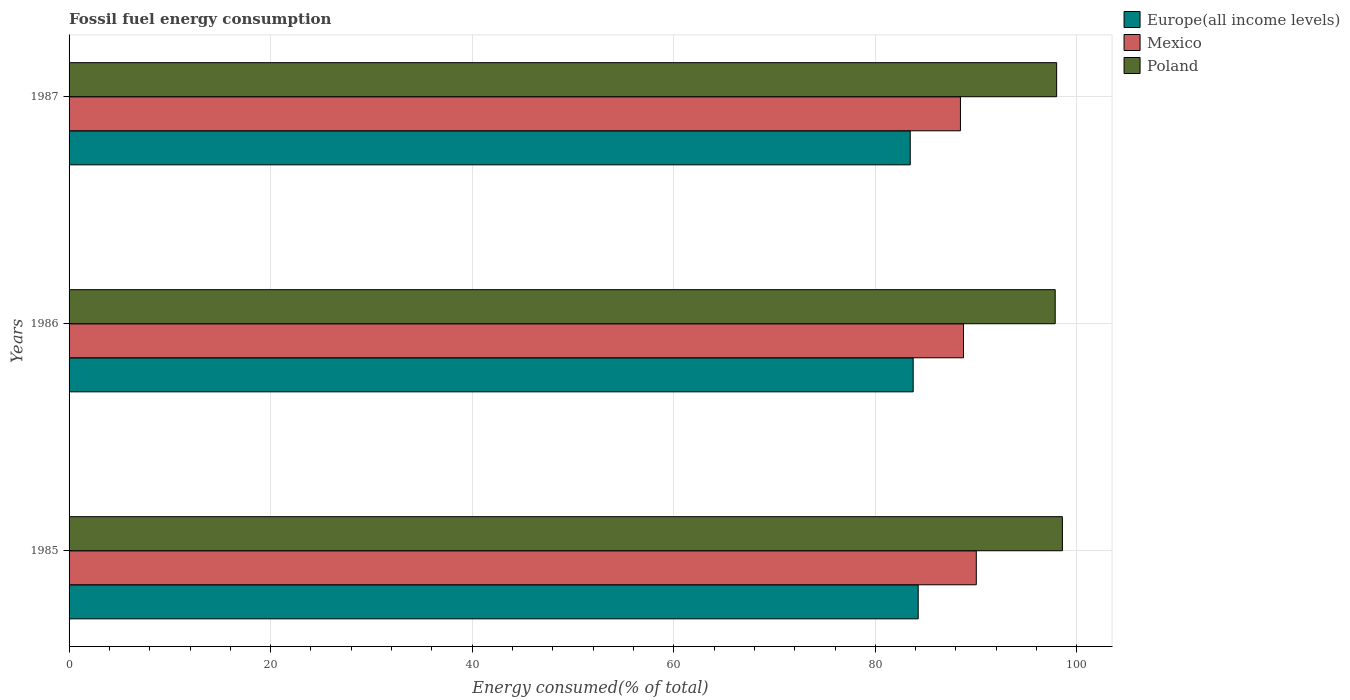How many different coloured bars are there?
Your answer should be compact. 3. Are the number of bars per tick equal to the number of legend labels?
Your response must be concise. Yes. What is the label of the 2nd group of bars from the top?
Offer a very short reply. 1986. In how many cases, is the number of bars for a given year not equal to the number of legend labels?
Make the answer very short. 0. What is the percentage of energy consumed in Poland in 1986?
Your answer should be compact. 97.85. Across all years, what is the maximum percentage of energy consumed in Mexico?
Give a very brief answer. 90.02. Across all years, what is the minimum percentage of energy consumed in Europe(all income levels)?
Make the answer very short. 83.46. In which year was the percentage of energy consumed in Poland minimum?
Provide a succinct answer. 1986. What is the total percentage of energy consumed in Mexico in the graph?
Your response must be concise. 267.21. What is the difference between the percentage of energy consumed in Europe(all income levels) in 1985 and that in 1987?
Offer a very short reply. 0.79. What is the difference between the percentage of energy consumed in Mexico in 1985 and the percentage of energy consumed in Poland in 1986?
Provide a succinct answer. -7.83. What is the average percentage of energy consumed in Mexico per year?
Ensure brevity in your answer.  89.07. In the year 1987, what is the difference between the percentage of energy consumed in Europe(all income levels) and percentage of energy consumed in Poland?
Give a very brief answer. -14.53. What is the ratio of the percentage of energy consumed in Mexico in 1985 to that in 1987?
Provide a short and direct response. 1.02. What is the difference between the highest and the second highest percentage of energy consumed in Poland?
Your answer should be compact. 0.57. What is the difference between the highest and the lowest percentage of energy consumed in Europe(all income levels)?
Your answer should be very brief. 0.79. In how many years, is the percentage of energy consumed in Europe(all income levels) greater than the average percentage of energy consumed in Europe(all income levels) taken over all years?
Make the answer very short. 1. What does the 2nd bar from the top in 1985 represents?
Your answer should be very brief. Mexico. What does the 1st bar from the bottom in 1985 represents?
Keep it short and to the point. Europe(all income levels). Is it the case that in every year, the sum of the percentage of energy consumed in Europe(all income levels) and percentage of energy consumed in Mexico is greater than the percentage of energy consumed in Poland?
Keep it short and to the point. Yes. How many bars are there?
Your answer should be compact. 9. Are all the bars in the graph horizontal?
Your answer should be compact. Yes. How many years are there in the graph?
Offer a very short reply. 3. Does the graph contain grids?
Provide a succinct answer. Yes. How many legend labels are there?
Offer a very short reply. 3. How are the legend labels stacked?
Ensure brevity in your answer.  Vertical. What is the title of the graph?
Your response must be concise. Fossil fuel energy consumption. Does "St. Kitts and Nevis" appear as one of the legend labels in the graph?
Your answer should be compact. No. What is the label or title of the X-axis?
Keep it short and to the point. Energy consumed(% of total). What is the Energy consumed(% of total) in Europe(all income levels) in 1985?
Keep it short and to the point. 84.25. What is the Energy consumed(% of total) in Mexico in 1985?
Offer a very short reply. 90.02. What is the Energy consumed(% of total) of Poland in 1985?
Provide a succinct answer. 98.56. What is the Energy consumed(% of total) of Europe(all income levels) in 1986?
Make the answer very short. 83.75. What is the Energy consumed(% of total) of Mexico in 1986?
Provide a succinct answer. 88.75. What is the Energy consumed(% of total) in Poland in 1986?
Offer a terse response. 97.85. What is the Energy consumed(% of total) of Europe(all income levels) in 1987?
Your answer should be very brief. 83.46. What is the Energy consumed(% of total) in Mexico in 1987?
Give a very brief answer. 88.44. What is the Energy consumed(% of total) in Poland in 1987?
Your answer should be very brief. 97.99. Across all years, what is the maximum Energy consumed(% of total) of Europe(all income levels)?
Make the answer very short. 84.25. Across all years, what is the maximum Energy consumed(% of total) in Mexico?
Offer a very short reply. 90.02. Across all years, what is the maximum Energy consumed(% of total) in Poland?
Provide a short and direct response. 98.56. Across all years, what is the minimum Energy consumed(% of total) in Europe(all income levels)?
Offer a very short reply. 83.46. Across all years, what is the minimum Energy consumed(% of total) of Mexico?
Offer a very short reply. 88.44. Across all years, what is the minimum Energy consumed(% of total) of Poland?
Make the answer very short. 97.85. What is the total Energy consumed(% of total) of Europe(all income levels) in the graph?
Keep it short and to the point. 251.47. What is the total Energy consumed(% of total) in Mexico in the graph?
Your response must be concise. 267.21. What is the total Energy consumed(% of total) of Poland in the graph?
Ensure brevity in your answer.  294.39. What is the difference between the Energy consumed(% of total) of Europe(all income levels) in 1985 and that in 1986?
Provide a succinct answer. 0.5. What is the difference between the Energy consumed(% of total) of Mexico in 1985 and that in 1986?
Give a very brief answer. 1.27. What is the difference between the Energy consumed(% of total) of Poland in 1985 and that in 1986?
Make the answer very short. 0.71. What is the difference between the Energy consumed(% of total) of Europe(all income levels) in 1985 and that in 1987?
Give a very brief answer. 0.79. What is the difference between the Energy consumed(% of total) of Mexico in 1985 and that in 1987?
Offer a terse response. 1.57. What is the difference between the Energy consumed(% of total) of Poland in 1985 and that in 1987?
Provide a succinct answer. 0.57. What is the difference between the Energy consumed(% of total) in Europe(all income levels) in 1986 and that in 1987?
Give a very brief answer. 0.29. What is the difference between the Energy consumed(% of total) of Mexico in 1986 and that in 1987?
Offer a terse response. 0.3. What is the difference between the Energy consumed(% of total) in Poland in 1986 and that in 1987?
Give a very brief answer. -0.14. What is the difference between the Energy consumed(% of total) of Europe(all income levels) in 1985 and the Energy consumed(% of total) of Mexico in 1986?
Provide a succinct answer. -4.49. What is the difference between the Energy consumed(% of total) in Europe(all income levels) in 1985 and the Energy consumed(% of total) in Poland in 1986?
Offer a terse response. -13.59. What is the difference between the Energy consumed(% of total) in Mexico in 1985 and the Energy consumed(% of total) in Poland in 1986?
Provide a short and direct response. -7.83. What is the difference between the Energy consumed(% of total) of Europe(all income levels) in 1985 and the Energy consumed(% of total) of Mexico in 1987?
Keep it short and to the point. -4.19. What is the difference between the Energy consumed(% of total) in Europe(all income levels) in 1985 and the Energy consumed(% of total) in Poland in 1987?
Your answer should be very brief. -13.74. What is the difference between the Energy consumed(% of total) of Mexico in 1985 and the Energy consumed(% of total) of Poland in 1987?
Your answer should be compact. -7.97. What is the difference between the Energy consumed(% of total) of Europe(all income levels) in 1986 and the Energy consumed(% of total) of Mexico in 1987?
Your answer should be very brief. -4.69. What is the difference between the Energy consumed(% of total) in Europe(all income levels) in 1986 and the Energy consumed(% of total) in Poland in 1987?
Ensure brevity in your answer.  -14.23. What is the difference between the Energy consumed(% of total) of Mexico in 1986 and the Energy consumed(% of total) of Poland in 1987?
Offer a very short reply. -9.24. What is the average Energy consumed(% of total) of Europe(all income levels) per year?
Provide a succinct answer. 83.82. What is the average Energy consumed(% of total) in Mexico per year?
Provide a short and direct response. 89.07. What is the average Energy consumed(% of total) in Poland per year?
Provide a succinct answer. 98.13. In the year 1985, what is the difference between the Energy consumed(% of total) of Europe(all income levels) and Energy consumed(% of total) of Mexico?
Your answer should be compact. -5.76. In the year 1985, what is the difference between the Energy consumed(% of total) of Europe(all income levels) and Energy consumed(% of total) of Poland?
Your answer should be compact. -14.31. In the year 1985, what is the difference between the Energy consumed(% of total) in Mexico and Energy consumed(% of total) in Poland?
Give a very brief answer. -8.54. In the year 1986, what is the difference between the Energy consumed(% of total) of Europe(all income levels) and Energy consumed(% of total) of Mexico?
Keep it short and to the point. -4.99. In the year 1986, what is the difference between the Energy consumed(% of total) of Europe(all income levels) and Energy consumed(% of total) of Poland?
Your answer should be compact. -14.09. In the year 1986, what is the difference between the Energy consumed(% of total) of Mexico and Energy consumed(% of total) of Poland?
Provide a succinct answer. -9.1. In the year 1987, what is the difference between the Energy consumed(% of total) in Europe(all income levels) and Energy consumed(% of total) in Mexico?
Your answer should be very brief. -4.98. In the year 1987, what is the difference between the Energy consumed(% of total) of Europe(all income levels) and Energy consumed(% of total) of Poland?
Ensure brevity in your answer.  -14.53. In the year 1987, what is the difference between the Energy consumed(% of total) of Mexico and Energy consumed(% of total) of Poland?
Provide a short and direct response. -9.55. What is the ratio of the Energy consumed(% of total) of Europe(all income levels) in 1985 to that in 1986?
Keep it short and to the point. 1.01. What is the ratio of the Energy consumed(% of total) in Mexico in 1985 to that in 1986?
Keep it short and to the point. 1.01. What is the ratio of the Energy consumed(% of total) in Poland in 1985 to that in 1986?
Provide a short and direct response. 1.01. What is the ratio of the Energy consumed(% of total) of Europe(all income levels) in 1985 to that in 1987?
Provide a short and direct response. 1.01. What is the ratio of the Energy consumed(% of total) in Mexico in 1985 to that in 1987?
Ensure brevity in your answer.  1.02. What is the difference between the highest and the second highest Energy consumed(% of total) of Europe(all income levels)?
Offer a very short reply. 0.5. What is the difference between the highest and the second highest Energy consumed(% of total) of Mexico?
Keep it short and to the point. 1.27. What is the difference between the highest and the second highest Energy consumed(% of total) in Poland?
Make the answer very short. 0.57. What is the difference between the highest and the lowest Energy consumed(% of total) in Europe(all income levels)?
Offer a very short reply. 0.79. What is the difference between the highest and the lowest Energy consumed(% of total) in Mexico?
Give a very brief answer. 1.57. What is the difference between the highest and the lowest Energy consumed(% of total) of Poland?
Keep it short and to the point. 0.71. 